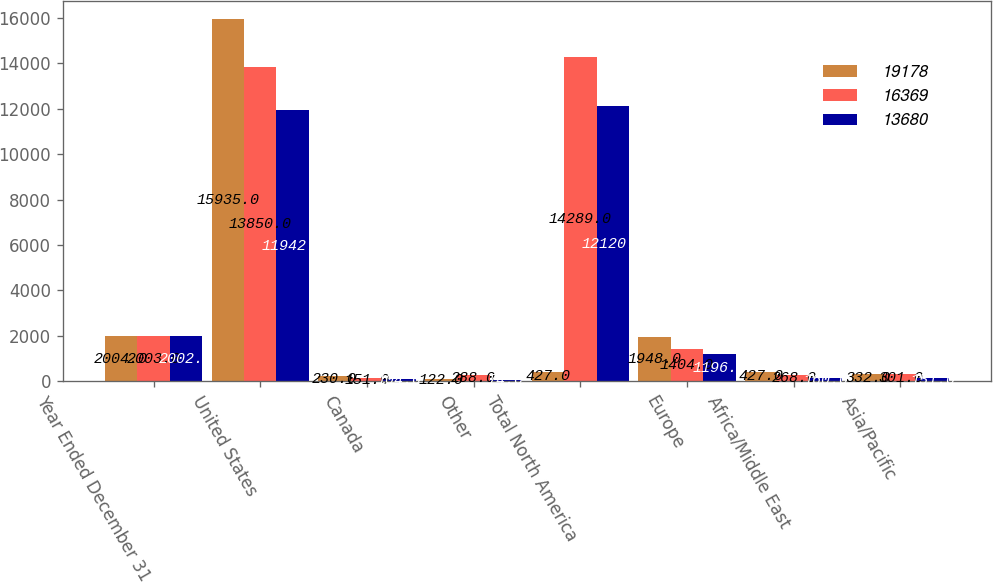Convert chart. <chart><loc_0><loc_0><loc_500><loc_500><stacked_bar_chart><ecel><fcel>Year Ended December 31<fcel>United States<fcel>Canada<fcel>Other<fcel>Total North America<fcel>Europe<fcel>Africa/Middle East<fcel>Asia/Pacific<nl><fcel>19178<fcel>2004<fcel>15935<fcel>230<fcel>122<fcel>427<fcel>1948<fcel>427<fcel>332<nl><fcel>16369<fcel>2003<fcel>13850<fcel>151<fcel>288<fcel>14289<fcel>1404<fcel>268<fcel>301<nl><fcel>13680<fcel>2002<fcel>11942<fcel>104<fcel>74<fcel>12120<fcel>1196<fcel>160<fcel>151<nl></chart> 